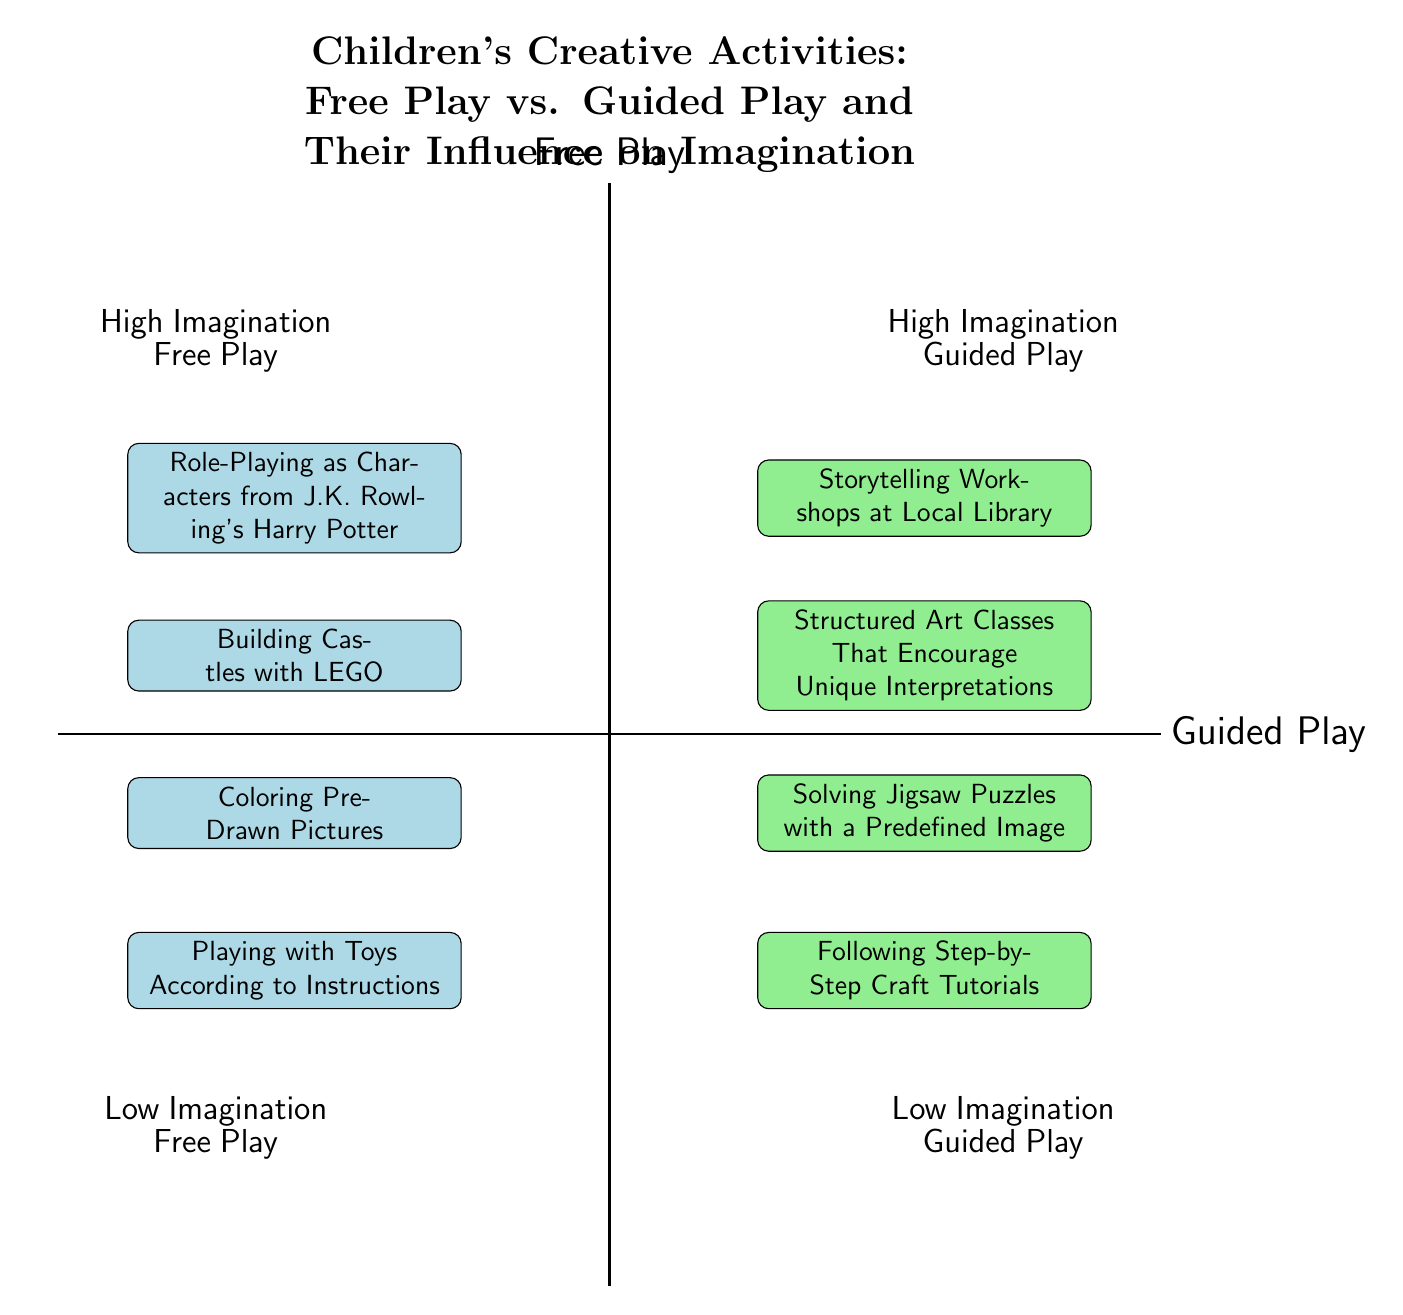What activities are in the High Imagination Free Play quadrant? The High Imagination Free Play quadrant contains activities that foster creativity without structured guidance. According to the diagram, the specific activities listed there are "Role-Playing as Characters from J.K. Rowling's Harry Potter" and "Building Castles with LEGO".
Answer: Role-Playing as Characters from J.K. Rowling's Harry Potter, Building Castles with LEGO How many activities are in the Low Imagination Guided Play quadrant? The Low Imagination Guided Play quadrant includes activities that are more structured and less imaginative. The activities listed are "Following Step-by-Step Craft Tutorials" and "Solving Jigsaw Puzzles with a Predefined Image". There are a total of 2 activities in this quadrant.
Answer: 2 What type of play is characterized by "Storytelling Workshops at Local Library"? This specific activity is found in the quadrant labeled High Imagination Guided Play. The diagram indicates that this activity is a guided play experience aimed at enhancing creativity.
Answer: Guided Play Which quadrant has activities that promote creativity without instructions? The Free Play quadrant is designed for activities that do not follow specific instructions, allowing for more imaginative expression. The activities mentioned in this quadrant are associated with higher creativity.
Answer: Free Play How many quadrants are shown in the diagram? The diagram features four quadrants, each representing different combinations of play types and imagination levels: High Imagination Guided Play, High Imagination Free Play, Low Imagination Guided Play, and Low Imagination Free Play.
Answer: 4 What distinguishes High Imagination Free Play from Low Imagination Free Play? High Imagination Free Play includes activities that are open-ended and encourage imagination, like "Role-Playing as Characters from J.K. Rowling's Harry Potter". In contrast, Low Imagination Free Play involves structured activities that restrict creativity, such as "Playing with Toys According to Instructions". This distinction highlights the difference between open-ended exploration and rule-based play.
Answer: The level of imagination encouraged What is the relationship between guided play and structured activities? Guided play is typified by structured activities that facilitate creative expression, whereas activities in the Low Imagination Guided Play quadrant present a rigid format that may limit imaginative potential, like "Following Step-by-Step Craft Tutorials". Therefore, the relationship shows that, while guided play can enhance creativity, it can also manifest in a more restrictive form.
Answer: Structured activities Which activity is associated with High Imagination Guided Play? The High Imagination Guided Play quadrant contains "Storytelling Workshops at Local Library" and "Structured Art Classes That Encourage Unique Interpretations", both of which are designed to stimulate creativity through guidance rather than strict instruction. Therefore, any of these activities can be related to this type of play.
Answer: Storytelling Workshops at Local Library How do activities in Low Imagination Free Play affect children’s creativity? The activities in Low Imagination Free Play, such as "Playing with Toys According to Instructions" and "Coloring Pre-Drawn Pictures", provide little room for creativity, as they offer specific tasks to accomplish without engaging children’s imagination fully. Therefore, they negatively impact the expansion of creative skills and imaginative play.
Answer: They provide little room for creativity 